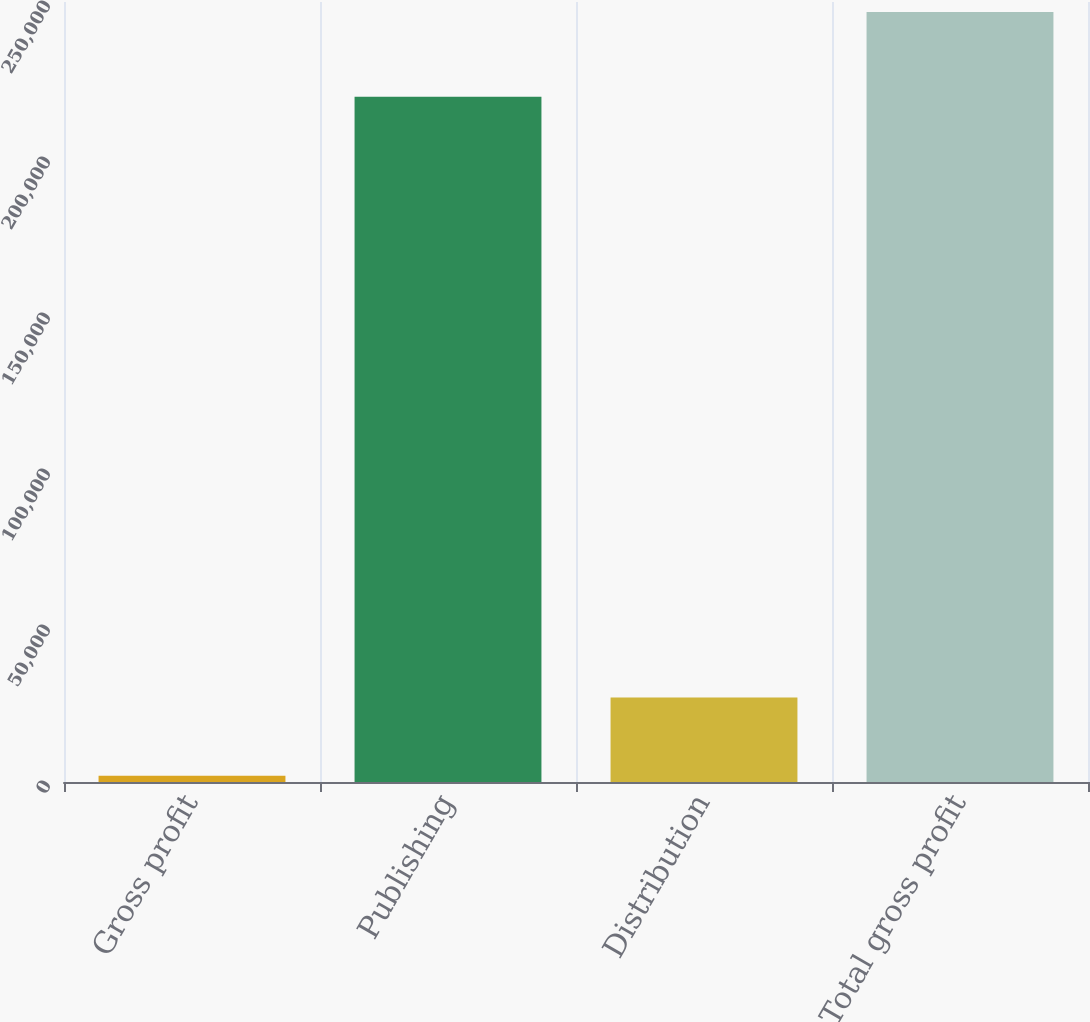<chart> <loc_0><loc_0><loc_500><loc_500><bar_chart><fcel>Gross profit<fcel>Publishing<fcel>Distribution<fcel>Total gross profit<nl><fcel>2007<fcel>219651<fcel>27106<fcel>246757<nl></chart> 